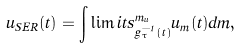<formula> <loc_0><loc_0><loc_500><loc_500>u _ { S E R } ( t ) = \int \lim i t s _ { g _ { \tau } ^ { - 1 } ( t ) } ^ { m _ { u } } u _ { m } ( t ) d m ,</formula> 